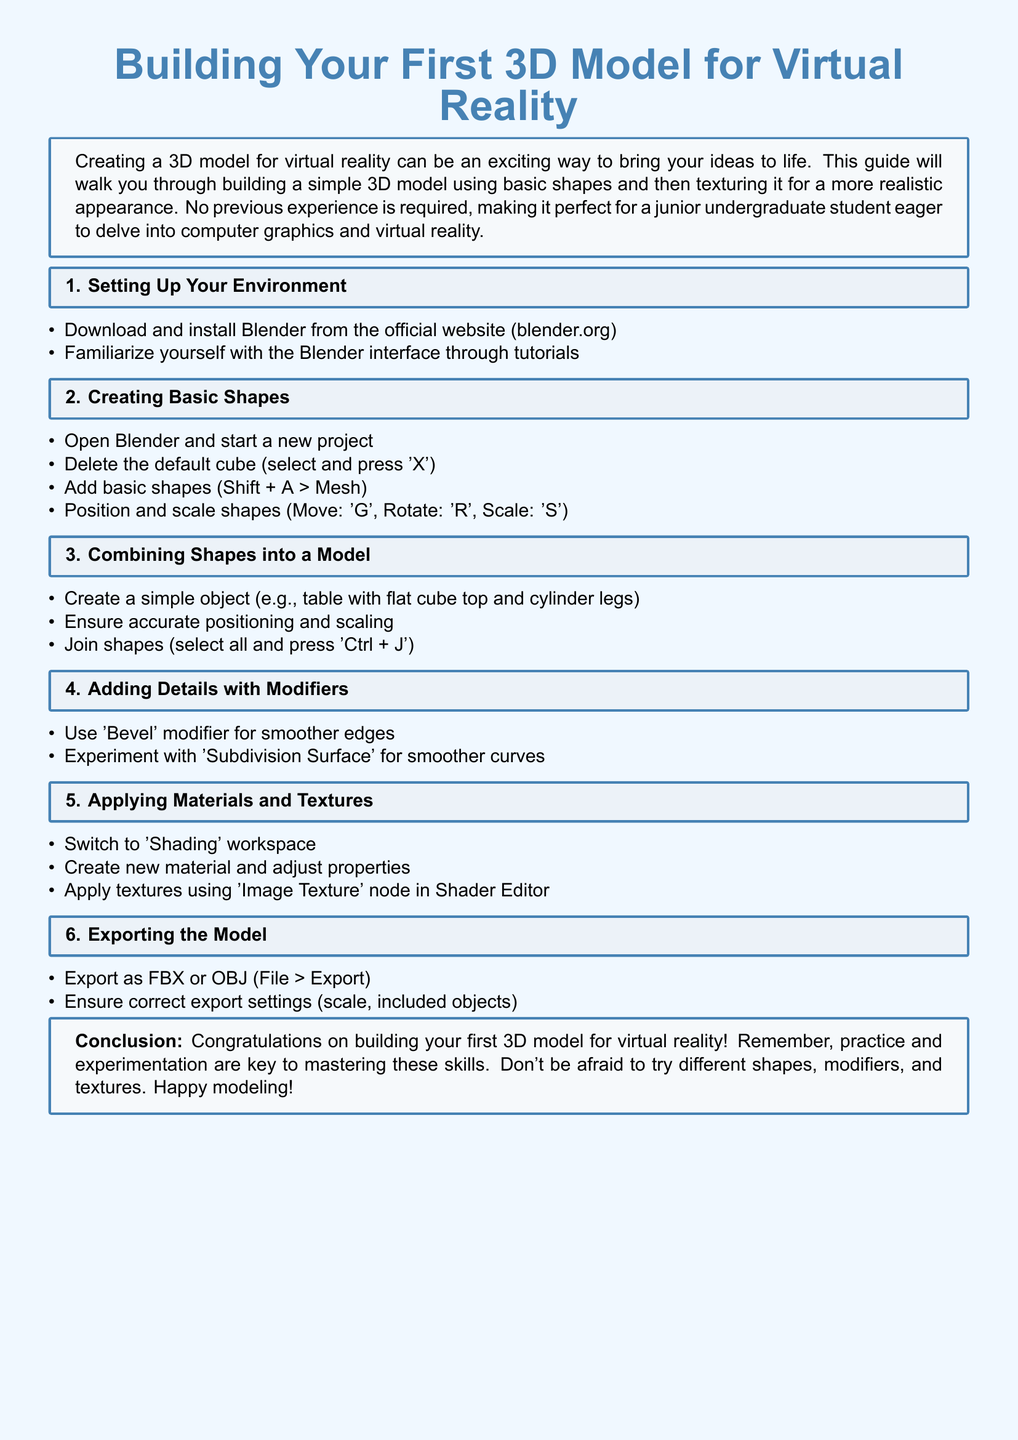What software should be downloaded to create 3D models? The instructions specify downloading and installing Blender from the official website.
Answer: Blender What key combination is used to add basic shapes in Blender? The document states the combination for adding shapes is Shift + A followed by selecting Mesh.
Answer: Shift + A What is the first step in setting up your environment according to the document? The document mentions downloading and installing Blender as the first step.
Answer: Download and install Blender What modifier is suggested for smoothing edges? The instructions specify using the Bevel modifier for smoother edges.
Answer: Bevel What file formats can the model be exported as? The document lists FBX and OBJ as the formats available for export.
Answer: FBX or OBJ What is the purpose of the Shading workspace in Blender? The document states that the Shading workspace is where you create new materials and adjust properties.
Answer: Create materials and adjust properties How can a group of shapes be joined into one model? The instructions indicate selecting all shapes and pressing Ctrl + J to join them.
Answer: Ctrl + J What kind of object is suggested for a simple model in the document? The document provides an example of creating a table with a flat cube top and cylinder legs.
Answer: Table 